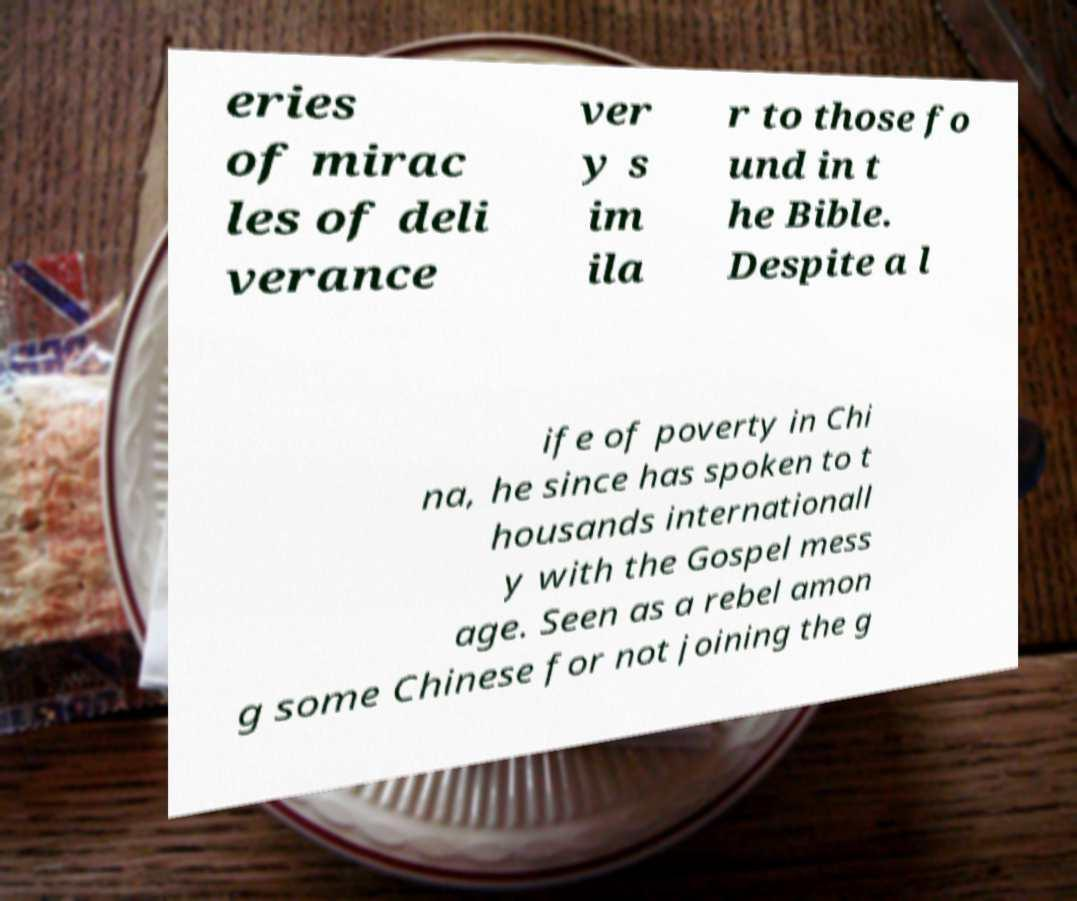Could you assist in decoding the text presented in this image and type it out clearly? eries of mirac les of deli verance ver y s im ila r to those fo und in t he Bible. Despite a l ife of poverty in Chi na, he since has spoken to t housands internationall y with the Gospel mess age. Seen as a rebel amon g some Chinese for not joining the g 